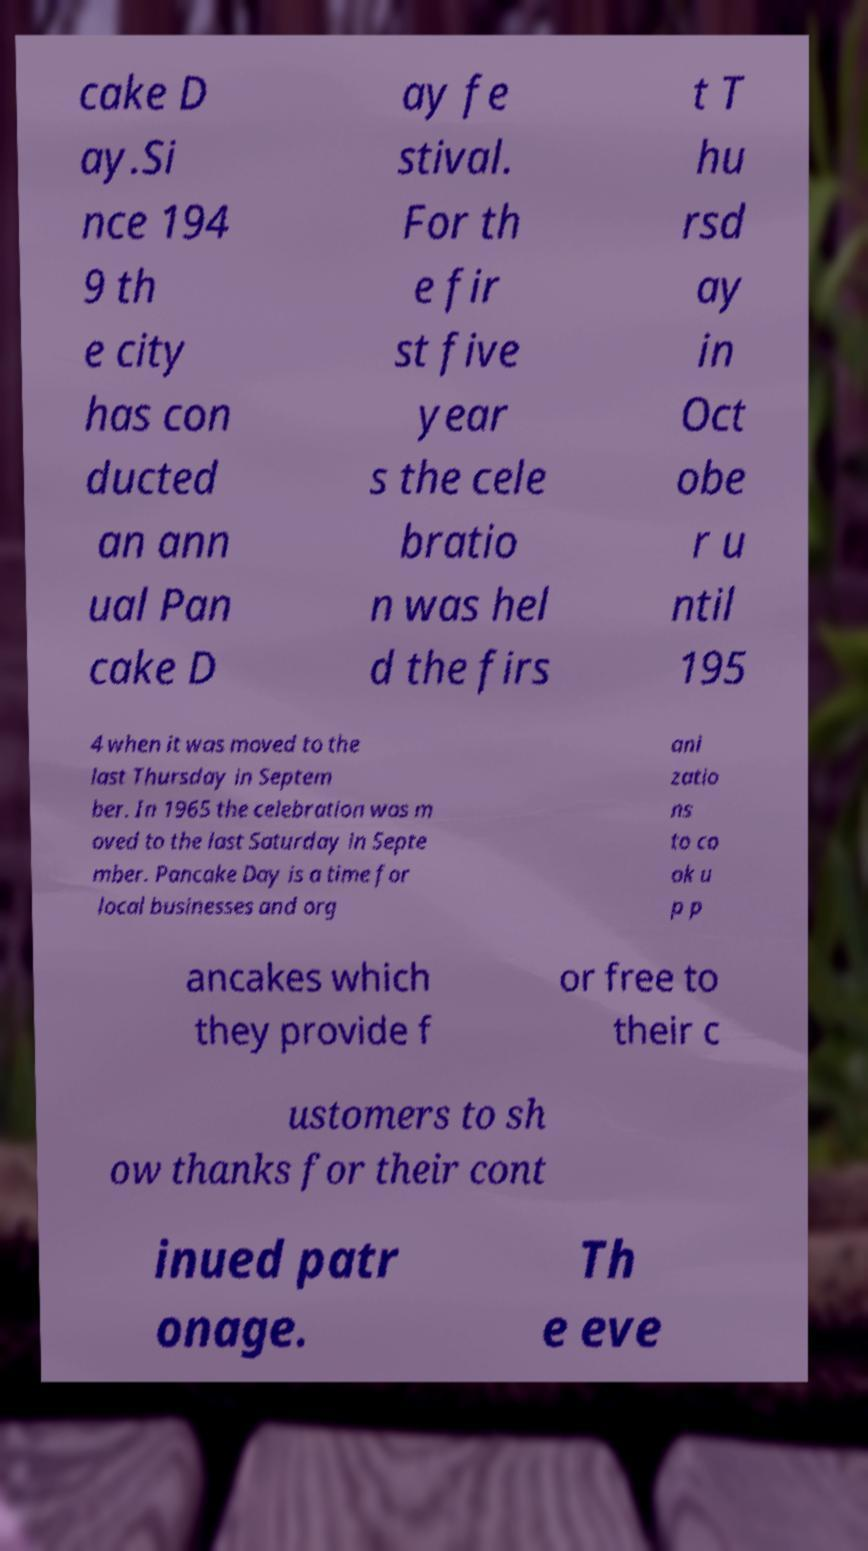What messages or text are displayed in this image? I need them in a readable, typed format. cake D ay.Si nce 194 9 th e city has con ducted an ann ual Pan cake D ay fe stival. For th e fir st five year s the cele bratio n was hel d the firs t T hu rsd ay in Oct obe r u ntil 195 4 when it was moved to the last Thursday in Septem ber. In 1965 the celebration was m oved to the last Saturday in Septe mber. Pancake Day is a time for local businesses and org ani zatio ns to co ok u p p ancakes which they provide f or free to their c ustomers to sh ow thanks for their cont inued patr onage. Th e eve 